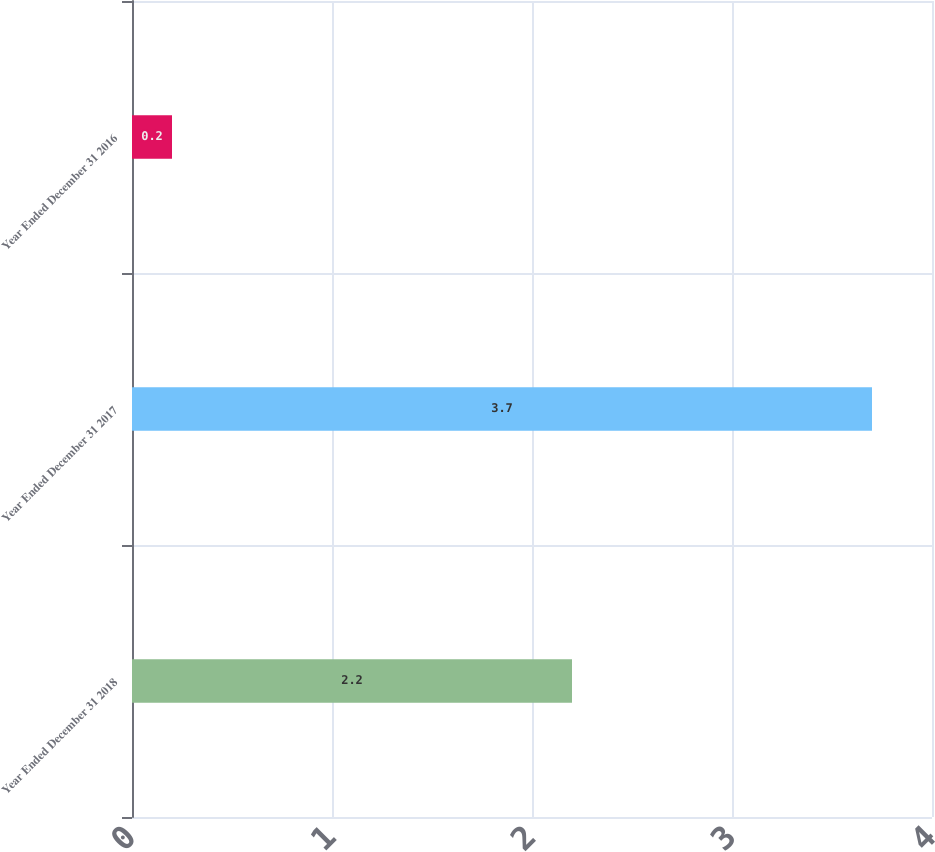Convert chart to OTSL. <chart><loc_0><loc_0><loc_500><loc_500><bar_chart><fcel>Year Ended December 31 2018<fcel>Year Ended December 31 2017<fcel>Year Ended December 31 2016<nl><fcel>2.2<fcel>3.7<fcel>0.2<nl></chart> 